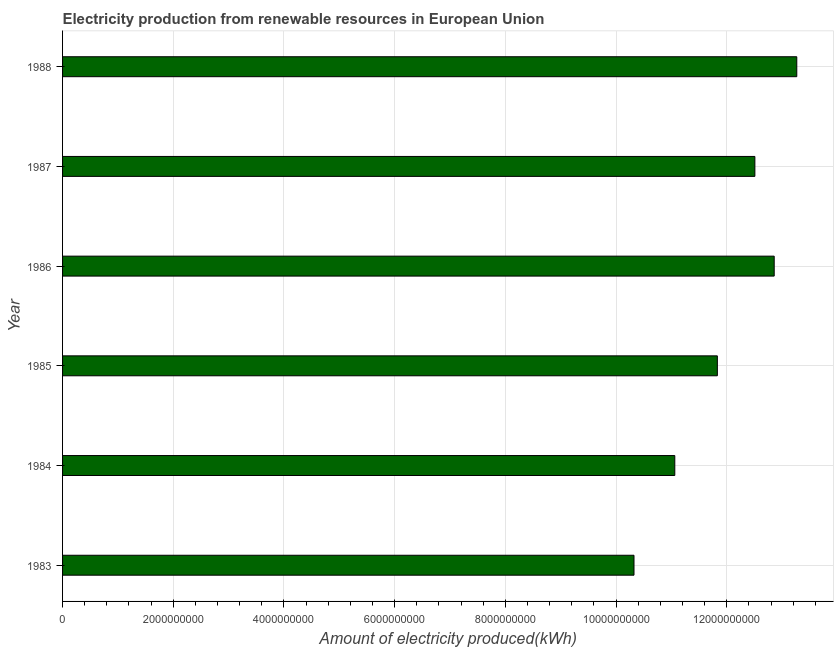Does the graph contain any zero values?
Make the answer very short. No. What is the title of the graph?
Your answer should be very brief. Electricity production from renewable resources in European Union. What is the label or title of the X-axis?
Keep it short and to the point. Amount of electricity produced(kWh). What is the label or title of the Y-axis?
Your answer should be compact. Year. What is the amount of electricity produced in 1983?
Provide a short and direct response. 1.03e+1. Across all years, what is the maximum amount of electricity produced?
Your answer should be very brief. 1.33e+1. Across all years, what is the minimum amount of electricity produced?
Your response must be concise. 1.03e+1. In which year was the amount of electricity produced minimum?
Provide a short and direct response. 1983. What is the sum of the amount of electricity produced?
Provide a short and direct response. 7.18e+1. What is the difference between the amount of electricity produced in 1983 and 1985?
Provide a succinct answer. -1.51e+09. What is the average amount of electricity produced per year?
Offer a terse response. 1.20e+1. What is the median amount of electricity produced?
Offer a terse response. 1.22e+1. In how many years, is the amount of electricity produced greater than 9200000000 kWh?
Your answer should be compact. 6. Do a majority of the years between 1987 and 1983 (inclusive) have amount of electricity produced greater than 2400000000 kWh?
Keep it short and to the point. Yes. What is the ratio of the amount of electricity produced in 1985 to that in 1987?
Offer a very short reply. 0.95. Is the amount of electricity produced in 1983 less than that in 1986?
Offer a terse response. Yes. What is the difference between the highest and the second highest amount of electricity produced?
Offer a terse response. 4.08e+08. Is the sum of the amount of electricity produced in 1983 and 1988 greater than the maximum amount of electricity produced across all years?
Provide a succinct answer. Yes. What is the difference between the highest and the lowest amount of electricity produced?
Provide a short and direct response. 2.94e+09. Are the values on the major ticks of X-axis written in scientific E-notation?
Your answer should be compact. No. What is the Amount of electricity produced(kWh) of 1983?
Make the answer very short. 1.03e+1. What is the Amount of electricity produced(kWh) of 1984?
Keep it short and to the point. 1.11e+1. What is the Amount of electricity produced(kWh) of 1985?
Your answer should be compact. 1.18e+1. What is the Amount of electricity produced(kWh) in 1986?
Keep it short and to the point. 1.29e+1. What is the Amount of electricity produced(kWh) in 1987?
Provide a short and direct response. 1.25e+1. What is the Amount of electricity produced(kWh) of 1988?
Your answer should be very brief. 1.33e+1. What is the difference between the Amount of electricity produced(kWh) in 1983 and 1984?
Your answer should be very brief. -7.37e+08. What is the difference between the Amount of electricity produced(kWh) in 1983 and 1985?
Your answer should be very brief. -1.51e+09. What is the difference between the Amount of electricity produced(kWh) in 1983 and 1986?
Your answer should be compact. -2.53e+09. What is the difference between the Amount of electricity produced(kWh) in 1983 and 1987?
Offer a very short reply. -2.18e+09. What is the difference between the Amount of electricity produced(kWh) in 1983 and 1988?
Provide a succinct answer. -2.94e+09. What is the difference between the Amount of electricity produced(kWh) in 1984 and 1985?
Ensure brevity in your answer.  -7.69e+08. What is the difference between the Amount of electricity produced(kWh) in 1984 and 1986?
Your answer should be very brief. -1.80e+09. What is the difference between the Amount of electricity produced(kWh) in 1984 and 1987?
Provide a succinct answer. -1.45e+09. What is the difference between the Amount of electricity produced(kWh) in 1984 and 1988?
Your answer should be compact. -2.20e+09. What is the difference between the Amount of electricity produced(kWh) in 1985 and 1986?
Your response must be concise. -1.03e+09. What is the difference between the Amount of electricity produced(kWh) in 1985 and 1987?
Your answer should be very brief. -6.78e+08. What is the difference between the Amount of electricity produced(kWh) in 1985 and 1988?
Make the answer very short. -1.44e+09. What is the difference between the Amount of electricity produced(kWh) in 1986 and 1987?
Provide a short and direct response. 3.49e+08. What is the difference between the Amount of electricity produced(kWh) in 1986 and 1988?
Your answer should be compact. -4.08e+08. What is the difference between the Amount of electricity produced(kWh) in 1987 and 1988?
Your response must be concise. -7.57e+08. What is the ratio of the Amount of electricity produced(kWh) in 1983 to that in 1984?
Provide a short and direct response. 0.93. What is the ratio of the Amount of electricity produced(kWh) in 1983 to that in 1985?
Give a very brief answer. 0.87. What is the ratio of the Amount of electricity produced(kWh) in 1983 to that in 1986?
Ensure brevity in your answer.  0.8. What is the ratio of the Amount of electricity produced(kWh) in 1983 to that in 1987?
Ensure brevity in your answer.  0.82. What is the ratio of the Amount of electricity produced(kWh) in 1983 to that in 1988?
Provide a short and direct response. 0.78. What is the ratio of the Amount of electricity produced(kWh) in 1984 to that in 1985?
Make the answer very short. 0.94. What is the ratio of the Amount of electricity produced(kWh) in 1984 to that in 1986?
Keep it short and to the point. 0.86. What is the ratio of the Amount of electricity produced(kWh) in 1984 to that in 1987?
Your answer should be compact. 0.88. What is the ratio of the Amount of electricity produced(kWh) in 1984 to that in 1988?
Offer a terse response. 0.83. What is the ratio of the Amount of electricity produced(kWh) in 1985 to that in 1987?
Your answer should be very brief. 0.95. What is the ratio of the Amount of electricity produced(kWh) in 1985 to that in 1988?
Your answer should be compact. 0.89. What is the ratio of the Amount of electricity produced(kWh) in 1986 to that in 1987?
Make the answer very short. 1.03. What is the ratio of the Amount of electricity produced(kWh) in 1987 to that in 1988?
Provide a short and direct response. 0.94. 